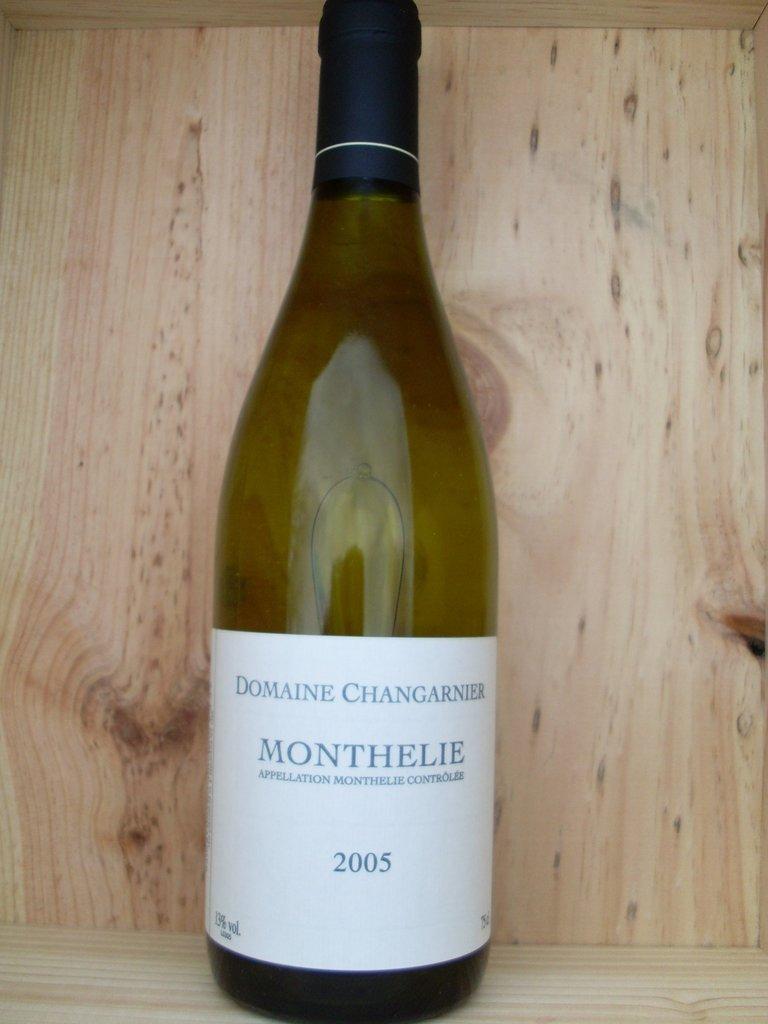What year is this wine?
Your response must be concise. 2005. 